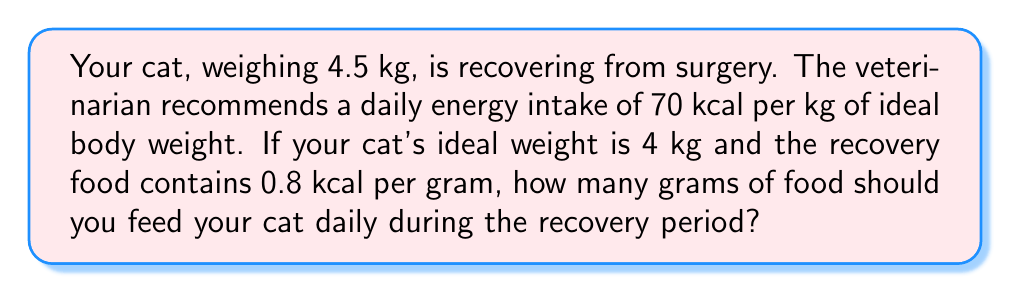Can you answer this question? Let's break this down step-by-step:

1. Calculate the daily energy requirement:
   $$\text{Daily Energy Requirement} = \text{Ideal Weight} \times \text{Energy per kg}$$
   $$\text{Daily Energy Requirement} = 4 \text{ kg} \times 70 \text{ kcal/kg} = 280 \text{ kcal}$$

2. Convert the food's energy density from kcal per gram to kcal per kg:
   $$0.8 \text{ kcal/g} = 800 \text{ kcal/kg}$$

3. Calculate the amount of food needed:
   $$\text{Food Amount} = \frac{\text{Daily Energy Requirement}}{\text{Food Energy Density}}$$
   $$\text{Food Amount} = \frac{280 \text{ kcal}}{800 \text{ kcal/kg}} = 0.35 \text{ kg}$$

4. Convert kg to grams:
   $$0.35 \text{ kg} = 350 \text{ g}$$

Therefore, you should feed your cat 350 grams of the recovery food daily.
Answer: 350 g 